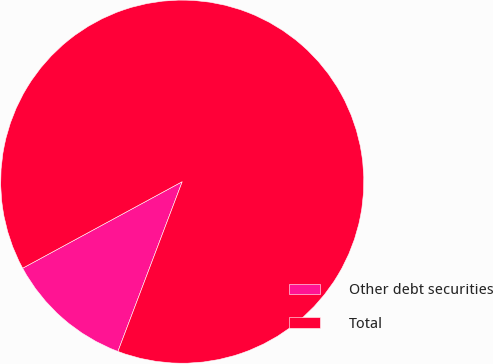Convert chart. <chart><loc_0><loc_0><loc_500><loc_500><pie_chart><fcel>Other debt securities<fcel>Total<nl><fcel>11.33%<fcel>88.67%<nl></chart> 